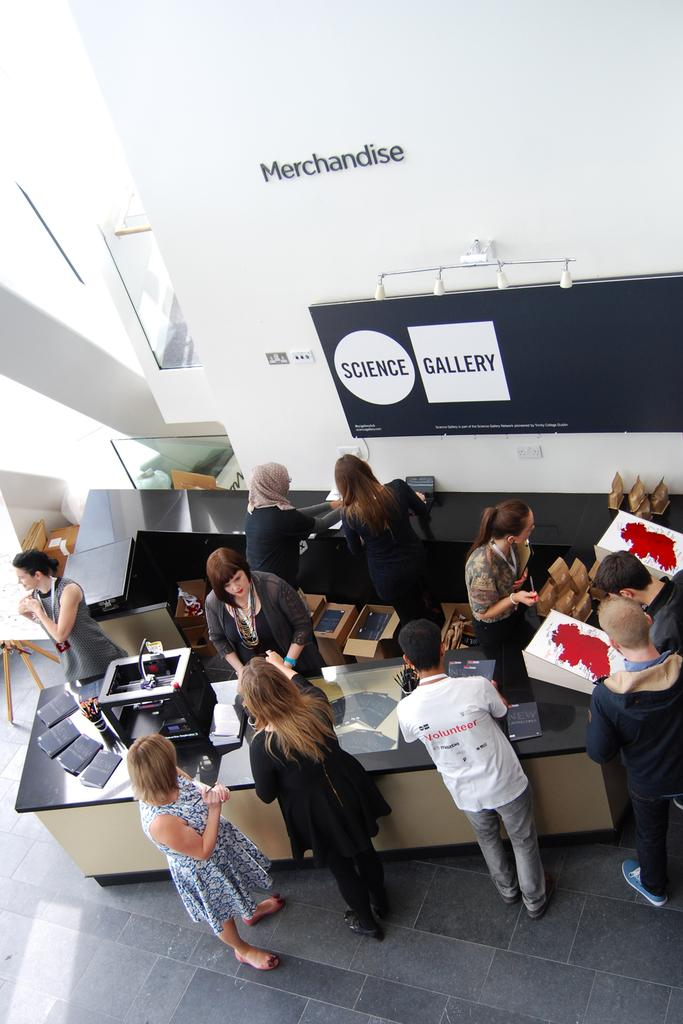What is the perspective of the image? The image is a top view of a room. What can be seen in the room from this perspective? There are people standing in the room. What type of brain can be seen in the image? There is no brain present in the image; it features a top view of a room with people standing in it. Can you tell me how many men are visible in the image? The provided facts do not specify the gender of the people in the image, so it cannot be definitively determined if there are men present. 